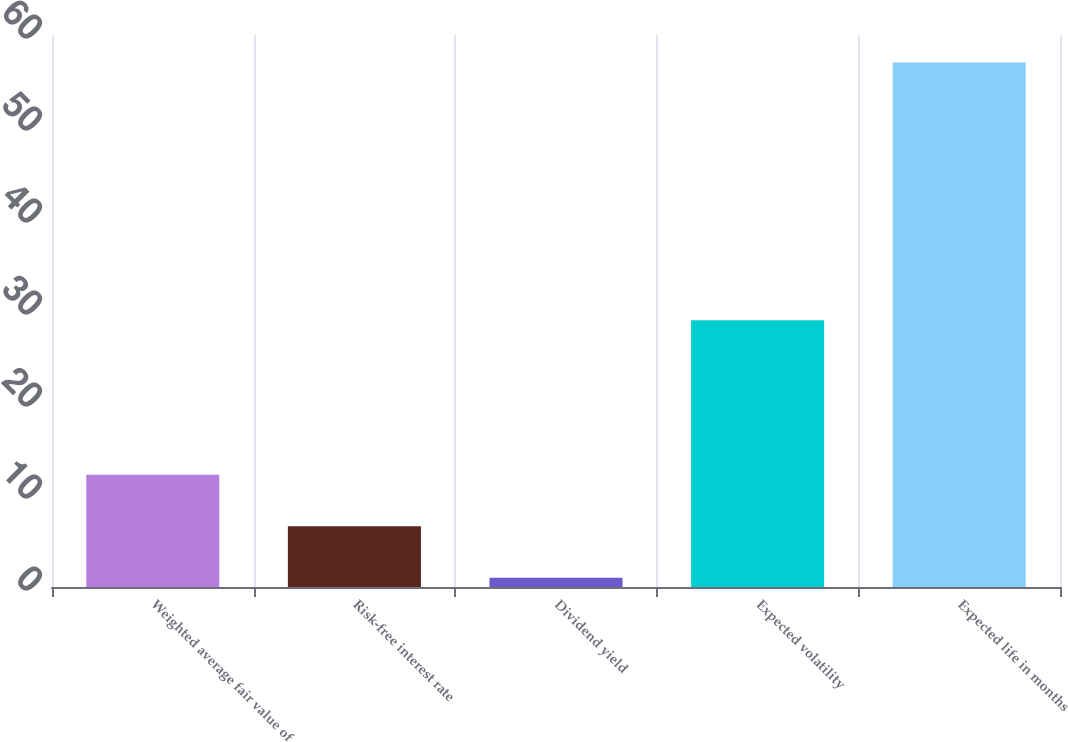Convert chart. <chart><loc_0><loc_0><loc_500><loc_500><bar_chart><fcel>Weighted average fair value of<fcel>Risk-free interest rate<fcel>Dividend yield<fcel>Expected volatility<fcel>Expected life in months<nl><fcel>12.2<fcel>6.6<fcel>1<fcel>29<fcel>57<nl></chart> 